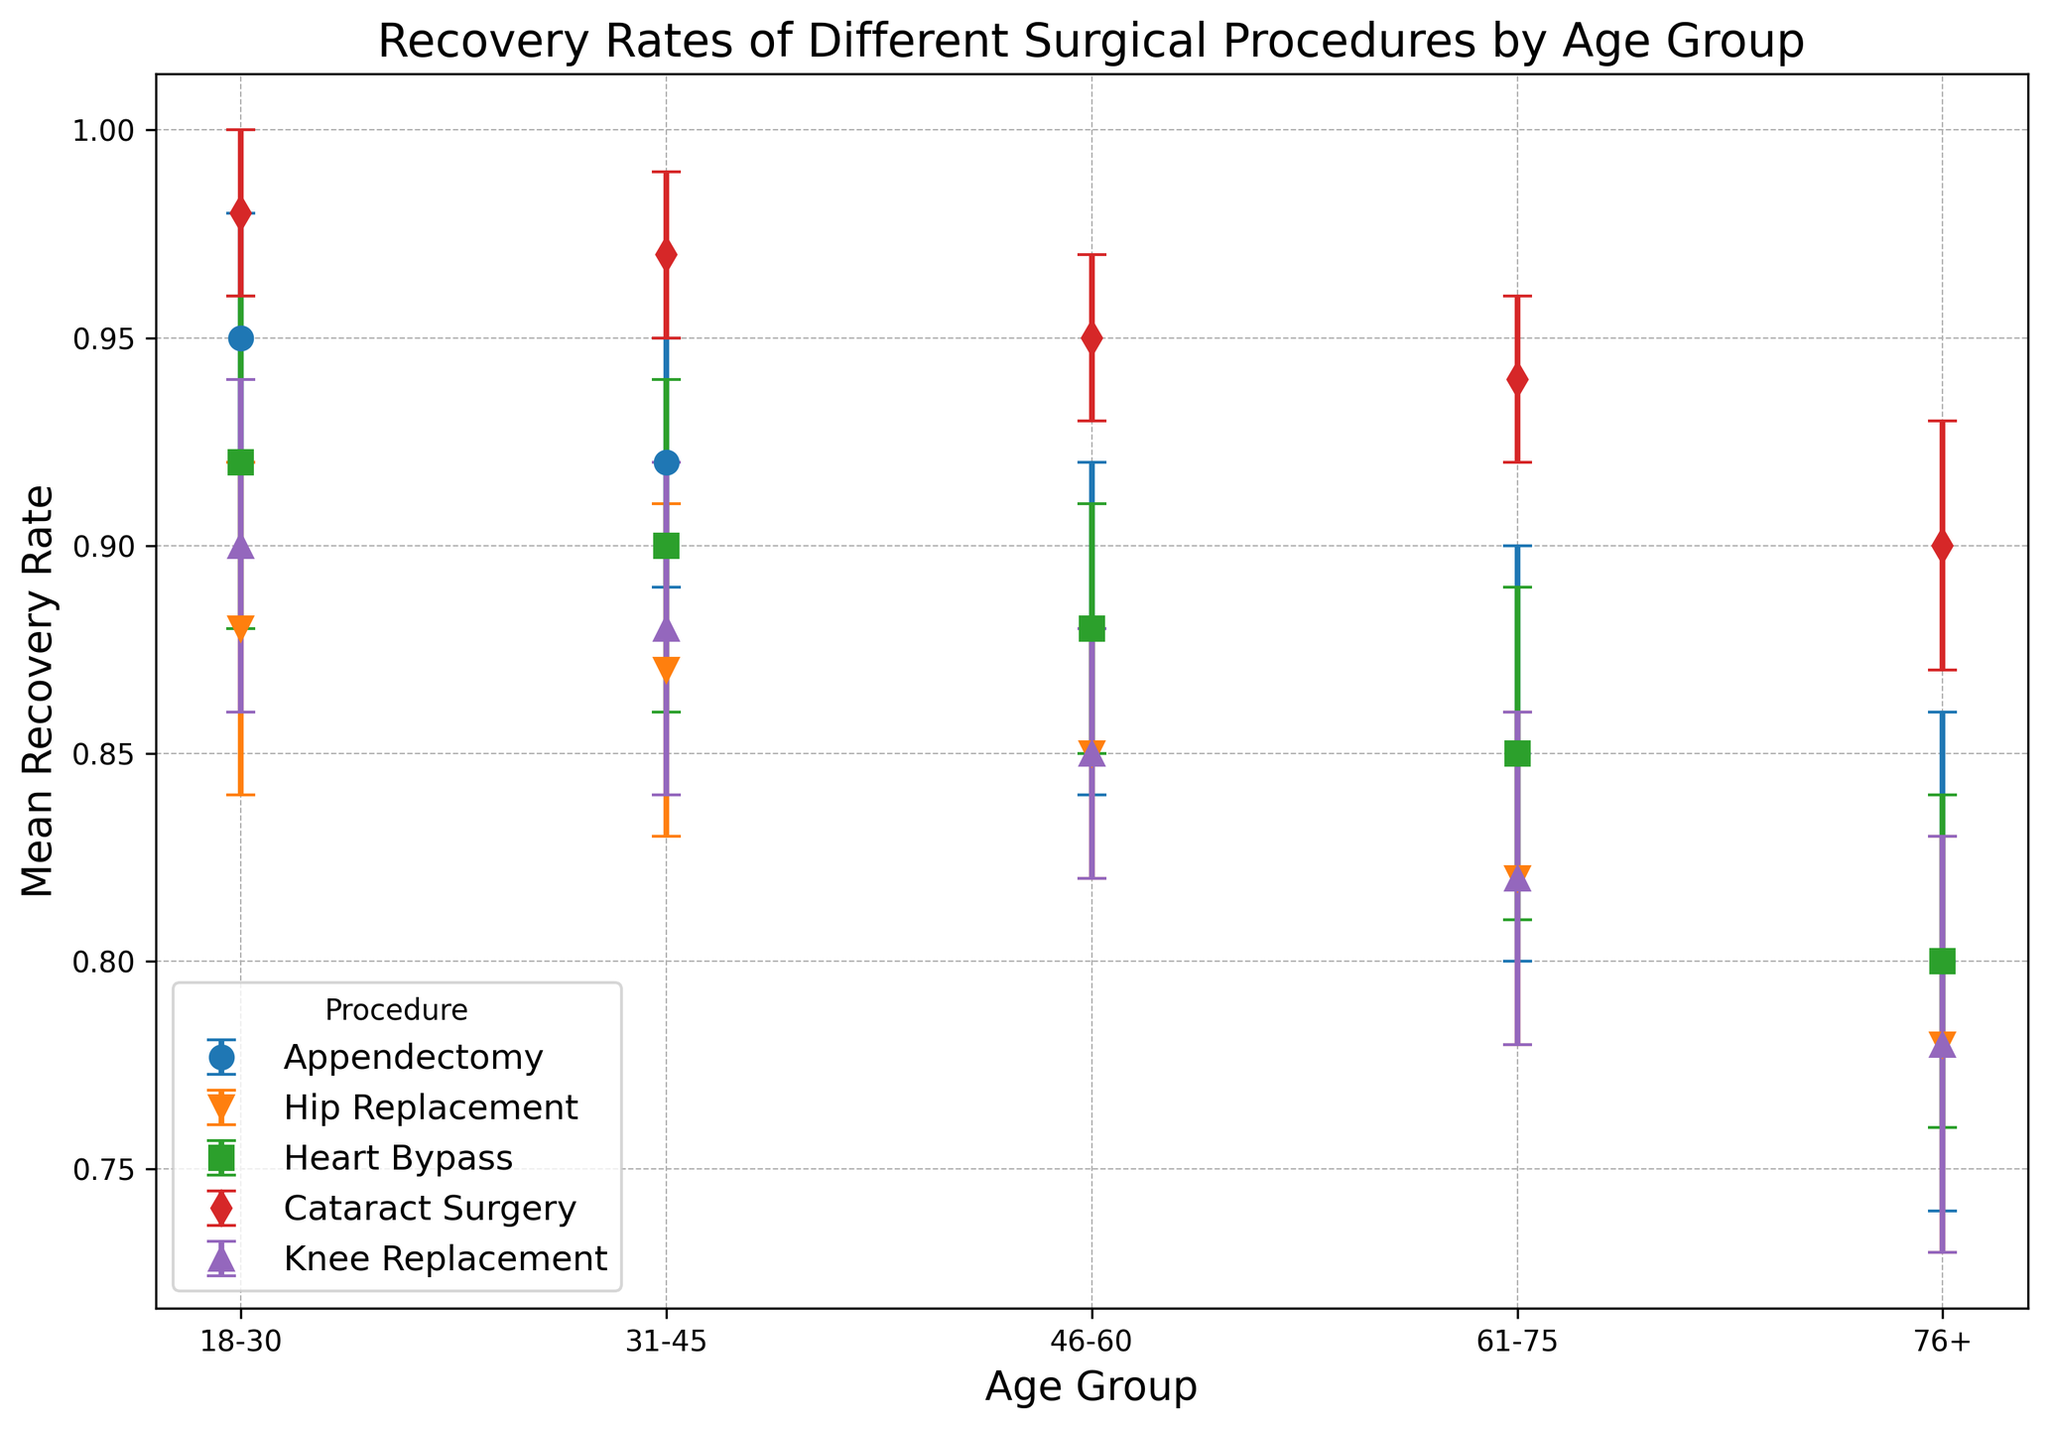Which surgical procedure has the highest recovery rate for the age group 18-30? The recovery rate for each surgical procedure in the age group 18-30 can be observed in the chart. The procedure with the highest recovery rate is the one closest to 1.
Answer: Cataract Surgery How does the recovery rate for Hip Replacement in the 61-75 age group compare to the 76+ age group? Locate the recovery rates for Hip Replacement in the 61-75 and 76+ age groups in the chart and compare their heights.
Answer: Higher in 61-75 What is the difference in the mean recovery rate between Appendectomy and Heart Bypass for the 31-45 age group? Find the mean recovery rates for Appendectomy and Heart Bypass in the 31-45 age group on the chart and calculate the difference.
Answer: 0.02 Which age group shows the greatest variation in recovery rates for Appendectomy? Examine the error bars for each age group's recovery rate for Appendectomy and identify the age group with the widest range (difference between upper and lower bounds).
Answer: 76+ Is the recovery rate for Heart Bypass consistently higher than for Knee Replacement across all age groups? Compare the recovery rates of Heart Bypass and Knee Replacement across each age group by examining the relative heights of the markers in the chart.
Answer: Yes What is the average recovery rate for Cataract Surgery across all age groups? Sum the mean recovery rates for Cataract Surgery in all age groups and then divide by the number of age groups (5).
Answer: 0.95 Which surgical procedure has the narrowest confidence interval in the age group 46-60? Look at the error bars for each surgical procedure in the age group 46-60 and identify the one with the shortest span (smallest difference between upper and lower bounds).
Answer: Cataract Surgery How does the mean recovery rate for Appendectomy change from the age group 18-30 to the age group 76+? Compare the mean recovery rates for Appendectomy in the age groups 18-30 and 76+ and calculate the difference.
Answer: Decreases by 0.15 In which age group does Knee Replacement show the smallest mean recovery rate? Identify the mean recovery rates for Knee Replacement across all age groups and find the smallest value.
Answer: 76+ What is the sum of the mean recovery rates for all surgical procedures in the 61-75 age group? Add the mean recovery rates for all five surgical procedures in the age group 61-75.
Answer: 4.28 